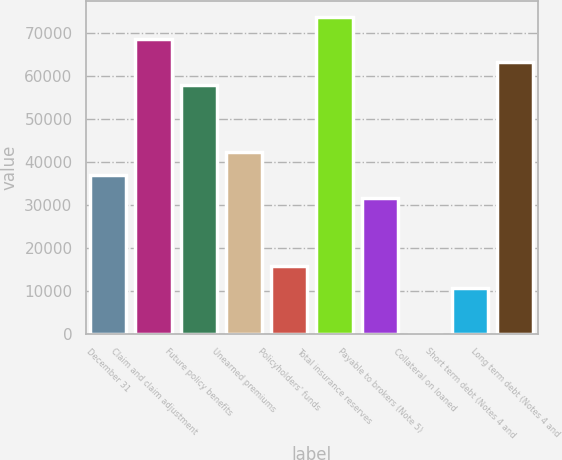<chart> <loc_0><loc_0><loc_500><loc_500><bar_chart><fcel>December 31<fcel>Claim and claim adjustment<fcel>Future policy benefits<fcel>Unearned premiums<fcel>Policyholders' funds<fcel>Total insurance reserves<fcel>Payable to brokers (Note 5)<fcel>Collateral on loaned<fcel>Short term debt (Notes 4 and<fcel>Long term debt (Notes 4 and<nl><fcel>36916.3<fcel>68553.7<fcel>58007.9<fcel>42189.2<fcel>15824.7<fcel>73826.6<fcel>31643.4<fcel>6<fcel>10551.8<fcel>63280.8<nl></chart> 